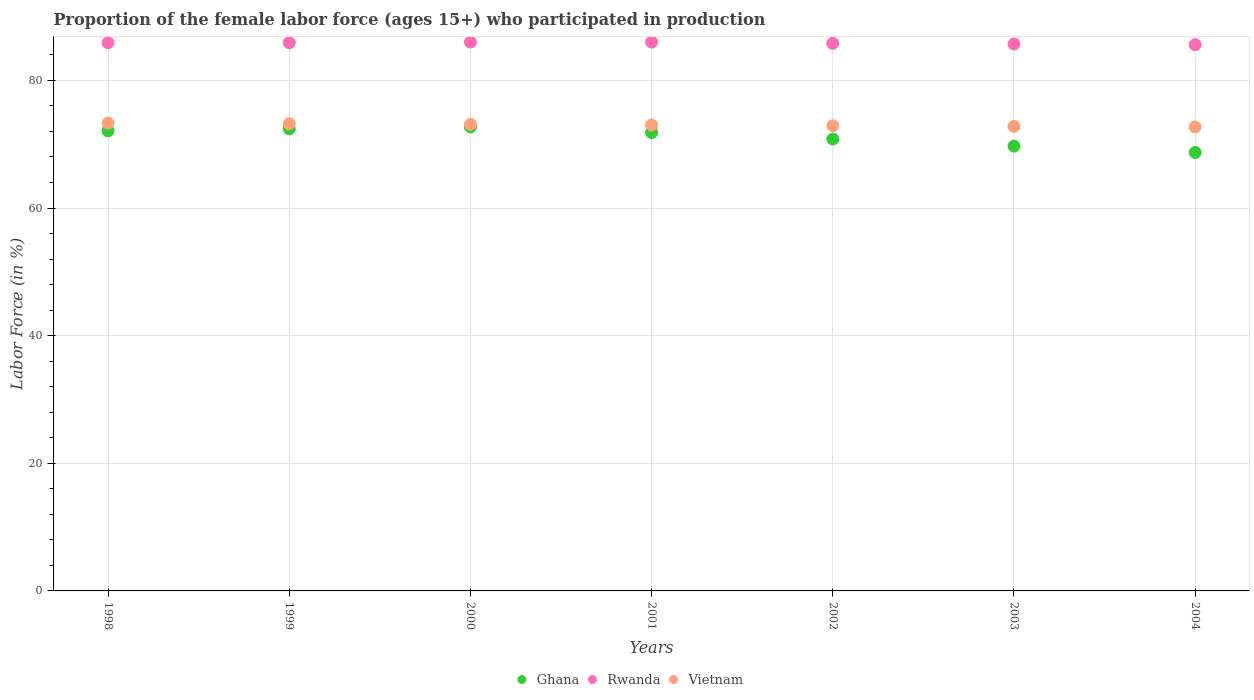What is the proportion of the female labor force who participated in production in Rwanda in 2002?
Your answer should be very brief. 85.8. Across all years, what is the minimum proportion of the female labor force who participated in production in Rwanda?
Give a very brief answer. 85.6. In which year was the proportion of the female labor force who participated in production in Vietnam maximum?
Offer a terse response. 1998. In which year was the proportion of the female labor force who participated in production in Ghana minimum?
Your answer should be compact. 2004. What is the total proportion of the female labor force who participated in production in Ghana in the graph?
Offer a terse response. 498.2. What is the difference between the proportion of the female labor force who participated in production in Vietnam in 2002 and that in 2004?
Your response must be concise. 0.2. What is the difference between the proportion of the female labor force who participated in production in Rwanda in 2004 and the proportion of the female labor force who participated in production in Ghana in 1999?
Offer a very short reply. 13.2. What is the average proportion of the female labor force who participated in production in Rwanda per year?
Make the answer very short. 85.84. In the year 1998, what is the difference between the proportion of the female labor force who participated in production in Ghana and proportion of the female labor force who participated in production in Rwanda?
Provide a succinct answer. -13.8. In how many years, is the proportion of the female labor force who participated in production in Rwanda greater than 8 %?
Give a very brief answer. 7. What is the ratio of the proportion of the female labor force who participated in production in Rwanda in 2001 to that in 2003?
Give a very brief answer. 1. Is the proportion of the female labor force who participated in production in Rwanda in 2001 less than that in 2004?
Ensure brevity in your answer.  No. Is the difference between the proportion of the female labor force who participated in production in Ghana in 1998 and 2002 greater than the difference between the proportion of the female labor force who participated in production in Rwanda in 1998 and 2002?
Make the answer very short. Yes. What is the difference between the highest and the second highest proportion of the female labor force who participated in production in Ghana?
Provide a short and direct response. 0.3. What is the difference between the highest and the lowest proportion of the female labor force who participated in production in Rwanda?
Your answer should be compact. 0.4. Is it the case that in every year, the sum of the proportion of the female labor force who participated in production in Rwanda and proportion of the female labor force who participated in production in Vietnam  is greater than the proportion of the female labor force who participated in production in Ghana?
Offer a very short reply. Yes. Is the proportion of the female labor force who participated in production in Vietnam strictly greater than the proportion of the female labor force who participated in production in Ghana over the years?
Offer a terse response. Yes. Is the proportion of the female labor force who participated in production in Rwanda strictly less than the proportion of the female labor force who participated in production in Vietnam over the years?
Offer a very short reply. No. How many years are there in the graph?
Offer a very short reply. 7. Are the values on the major ticks of Y-axis written in scientific E-notation?
Offer a terse response. No. Does the graph contain any zero values?
Offer a very short reply. No. Where does the legend appear in the graph?
Ensure brevity in your answer.  Bottom center. How are the legend labels stacked?
Provide a succinct answer. Horizontal. What is the title of the graph?
Provide a short and direct response. Proportion of the female labor force (ages 15+) who participated in production. Does "Norway" appear as one of the legend labels in the graph?
Provide a short and direct response. No. What is the label or title of the X-axis?
Provide a short and direct response. Years. What is the label or title of the Y-axis?
Your answer should be compact. Labor Force (in %). What is the Labor Force (in %) of Ghana in 1998?
Your answer should be very brief. 72.1. What is the Labor Force (in %) in Rwanda in 1998?
Your response must be concise. 85.9. What is the Labor Force (in %) in Vietnam in 1998?
Your answer should be compact. 73.3. What is the Labor Force (in %) in Ghana in 1999?
Offer a terse response. 72.4. What is the Labor Force (in %) of Rwanda in 1999?
Provide a succinct answer. 85.9. What is the Labor Force (in %) of Vietnam in 1999?
Provide a short and direct response. 73.2. What is the Labor Force (in %) in Ghana in 2000?
Make the answer very short. 72.7. What is the Labor Force (in %) in Rwanda in 2000?
Ensure brevity in your answer.  86. What is the Labor Force (in %) in Vietnam in 2000?
Offer a terse response. 73.1. What is the Labor Force (in %) of Ghana in 2001?
Make the answer very short. 71.8. What is the Labor Force (in %) in Vietnam in 2001?
Make the answer very short. 73. What is the Labor Force (in %) in Ghana in 2002?
Your response must be concise. 70.8. What is the Labor Force (in %) in Rwanda in 2002?
Make the answer very short. 85.8. What is the Labor Force (in %) of Vietnam in 2002?
Keep it short and to the point. 72.9. What is the Labor Force (in %) of Ghana in 2003?
Give a very brief answer. 69.7. What is the Labor Force (in %) of Rwanda in 2003?
Make the answer very short. 85.7. What is the Labor Force (in %) of Vietnam in 2003?
Ensure brevity in your answer.  72.8. What is the Labor Force (in %) in Ghana in 2004?
Your response must be concise. 68.7. What is the Labor Force (in %) in Rwanda in 2004?
Make the answer very short. 85.6. What is the Labor Force (in %) in Vietnam in 2004?
Offer a terse response. 72.7. Across all years, what is the maximum Labor Force (in %) in Ghana?
Your response must be concise. 72.7. Across all years, what is the maximum Labor Force (in %) of Vietnam?
Keep it short and to the point. 73.3. Across all years, what is the minimum Labor Force (in %) in Ghana?
Give a very brief answer. 68.7. Across all years, what is the minimum Labor Force (in %) in Rwanda?
Keep it short and to the point. 85.6. Across all years, what is the minimum Labor Force (in %) of Vietnam?
Your answer should be very brief. 72.7. What is the total Labor Force (in %) in Ghana in the graph?
Provide a succinct answer. 498.2. What is the total Labor Force (in %) of Rwanda in the graph?
Offer a terse response. 600.9. What is the total Labor Force (in %) in Vietnam in the graph?
Your answer should be compact. 511. What is the difference between the Labor Force (in %) of Rwanda in 1998 and that in 1999?
Provide a short and direct response. 0. What is the difference between the Labor Force (in %) in Vietnam in 1998 and that in 1999?
Offer a very short reply. 0.1. What is the difference between the Labor Force (in %) of Rwanda in 1998 and that in 2000?
Make the answer very short. -0.1. What is the difference between the Labor Force (in %) in Vietnam in 1998 and that in 2000?
Your answer should be compact. 0.2. What is the difference between the Labor Force (in %) in Ghana in 1998 and that in 2002?
Your response must be concise. 1.3. What is the difference between the Labor Force (in %) of Rwanda in 1998 and that in 2002?
Your answer should be very brief. 0.1. What is the difference between the Labor Force (in %) of Rwanda in 1998 and that in 2003?
Give a very brief answer. 0.2. What is the difference between the Labor Force (in %) in Ghana in 1998 and that in 2004?
Your answer should be compact. 3.4. What is the difference between the Labor Force (in %) in Rwanda in 1998 and that in 2004?
Your response must be concise. 0.3. What is the difference between the Labor Force (in %) of Vietnam in 1998 and that in 2004?
Offer a very short reply. 0.6. What is the difference between the Labor Force (in %) of Ghana in 1999 and that in 2000?
Your answer should be very brief. -0.3. What is the difference between the Labor Force (in %) of Rwanda in 1999 and that in 2000?
Provide a succinct answer. -0.1. What is the difference between the Labor Force (in %) in Vietnam in 1999 and that in 2000?
Give a very brief answer. 0.1. What is the difference between the Labor Force (in %) of Ghana in 1999 and that in 2001?
Your answer should be very brief. 0.6. What is the difference between the Labor Force (in %) of Rwanda in 1999 and that in 2002?
Your response must be concise. 0.1. What is the difference between the Labor Force (in %) of Rwanda in 1999 and that in 2004?
Offer a terse response. 0.3. What is the difference between the Labor Force (in %) in Vietnam in 1999 and that in 2004?
Ensure brevity in your answer.  0.5. What is the difference between the Labor Force (in %) in Ghana in 2000 and that in 2001?
Provide a short and direct response. 0.9. What is the difference between the Labor Force (in %) in Rwanda in 2000 and that in 2001?
Your answer should be very brief. 0. What is the difference between the Labor Force (in %) in Vietnam in 2000 and that in 2001?
Make the answer very short. 0.1. What is the difference between the Labor Force (in %) of Rwanda in 2000 and that in 2002?
Offer a terse response. 0.2. What is the difference between the Labor Force (in %) in Vietnam in 2000 and that in 2002?
Your answer should be very brief. 0.2. What is the difference between the Labor Force (in %) in Ghana in 2000 and that in 2003?
Make the answer very short. 3. What is the difference between the Labor Force (in %) of Ghana in 2000 and that in 2004?
Your response must be concise. 4. What is the difference between the Labor Force (in %) of Vietnam in 2000 and that in 2004?
Offer a very short reply. 0.4. What is the difference between the Labor Force (in %) of Ghana in 2001 and that in 2002?
Keep it short and to the point. 1. What is the difference between the Labor Force (in %) in Rwanda in 2001 and that in 2002?
Provide a succinct answer. 0.2. What is the difference between the Labor Force (in %) of Vietnam in 2001 and that in 2002?
Give a very brief answer. 0.1. What is the difference between the Labor Force (in %) in Rwanda in 2001 and that in 2003?
Give a very brief answer. 0.3. What is the difference between the Labor Force (in %) of Ghana in 2001 and that in 2004?
Ensure brevity in your answer.  3.1. What is the difference between the Labor Force (in %) in Vietnam in 2002 and that in 2003?
Offer a terse response. 0.1. What is the difference between the Labor Force (in %) in Ghana in 2002 and that in 2004?
Your answer should be compact. 2.1. What is the difference between the Labor Force (in %) of Vietnam in 2002 and that in 2004?
Your answer should be very brief. 0.2. What is the difference between the Labor Force (in %) in Vietnam in 2003 and that in 2004?
Your answer should be very brief. 0.1. What is the difference between the Labor Force (in %) in Ghana in 1998 and the Labor Force (in %) in Rwanda in 2000?
Your answer should be very brief. -13.9. What is the difference between the Labor Force (in %) in Rwanda in 1998 and the Labor Force (in %) in Vietnam in 2001?
Offer a very short reply. 12.9. What is the difference between the Labor Force (in %) in Ghana in 1998 and the Labor Force (in %) in Rwanda in 2002?
Ensure brevity in your answer.  -13.7. What is the difference between the Labor Force (in %) in Rwanda in 1998 and the Labor Force (in %) in Vietnam in 2002?
Keep it short and to the point. 13. What is the difference between the Labor Force (in %) of Ghana in 1998 and the Labor Force (in %) of Rwanda in 2003?
Give a very brief answer. -13.6. What is the difference between the Labor Force (in %) in Ghana in 1998 and the Labor Force (in %) in Vietnam in 2004?
Provide a short and direct response. -0.6. What is the difference between the Labor Force (in %) in Ghana in 1999 and the Labor Force (in %) in Rwanda in 2000?
Offer a very short reply. -13.6. What is the difference between the Labor Force (in %) of Ghana in 1999 and the Labor Force (in %) of Vietnam in 2000?
Your answer should be compact. -0.7. What is the difference between the Labor Force (in %) of Rwanda in 1999 and the Labor Force (in %) of Vietnam in 2000?
Offer a terse response. 12.8. What is the difference between the Labor Force (in %) in Ghana in 1999 and the Labor Force (in %) in Rwanda in 2001?
Offer a terse response. -13.6. What is the difference between the Labor Force (in %) in Ghana in 1999 and the Labor Force (in %) in Rwanda in 2002?
Offer a very short reply. -13.4. What is the difference between the Labor Force (in %) in Rwanda in 1999 and the Labor Force (in %) in Vietnam in 2002?
Make the answer very short. 13. What is the difference between the Labor Force (in %) of Ghana in 1999 and the Labor Force (in %) of Vietnam in 2003?
Your answer should be compact. -0.4. What is the difference between the Labor Force (in %) of Rwanda in 1999 and the Labor Force (in %) of Vietnam in 2003?
Give a very brief answer. 13.1. What is the difference between the Labor Force (in %) in Ghana in 1999 and the Labor Force (in %) in Rwanda in 2004?
Your response must be concise. -13.2. What is the difference between the Labor Force (in %) of Ghana in 1999 and the Labor Force (in %) of Vietnam in 2004?
Make the answer very short. -0.3. What is the difference between the Labor Force (in %) in Ghana in 2000 and the Labor Force (in %) in Vietnam in 2001?
Make the answer very short. -0.3. What is the difference between the Labor Force (in %) in Rwanda in 2000 and the Labor Force (in %) in Vietnam in 2001?
Make the answer very short. 13. What is the difference between the Labor Force (in %) in Ghana in 2000 and the Labor Force (in %) in Vietnam in 2002?
Provide a succinct answer. -0.2. What is the difference between the Labor Force (in %) of Ghana in 2000 and the Labor Force (in %) of Vietnam in 2003?
Provide a short and direct response. -0.1. What is the difference between the Labor Force (in %) in Ghana in 2000 and the Labor Force (in %) in Rwanda in 2004?
Provide a short and direct response. -12.9. What is the difference between the Labor Force (in %) in Ghana in 2001 and the Labor Force (in %) in Rwanda in 2002?
Offer a terse response. -14. What is the difference between the Labor Force (in %) in Ghana in 2001 and the Labor Force (in %) in Vietnam in 2003?
Give a very brief answer. -1. What is the difference between the Labor Force (in %) of Rwanda in 2001 and the Labor Force (in %) of Vietnam in 2003?
Provide a succinct answer. 13.2. What is the difference between the Labor Force (in %) of Ghana in 2001 and the Labor Force (in %) of Vietnam in 2004?
Your response must be concise. -0.9. What is the difference between the Labor Force (in %) of Ghana in 2002 and the Labor Force (in %) of Rwanda in 2003?
Give a very brief answer. -14.9. What is the difference between the Labor Force (in %) in Ghana in 2002 and the Labor Force (in %) in Vietnam in 2003?
Offer a terse response. -2. What is the difference between the Labor Force (in %) in Rwanda in 2002 and the Labor Force (in %) in Vietnam in 2003?
Your response must be concise. 13. What is the difference between the Labor Force (in %) in Ghana in 2002 and the Labor Force (in %) in Rwanda in 2004?
Offer a terse response. -14.8. What is the difference between the Labor Force (in %) of Rwanda in 2002 and the Labor Force (in %) of Vietnam in 2004?
Give a very brief answer. 13.1. What is the difference between the Labor Force (in %) in Ghana in 2003 and the Labor Force (in %) in Rwanda in 2004?
Offer a very short reply. -15.9. What is the average Labor Force (in %) in Ghana per year?
Your response must be concise. 71.17. What is the average Labor Force (in %) in Rwanda per year?
Keep it short and to the point. 85.84. In the year 1998, what is the difference between the Labor Force (in %) of Ghana and Labor Force (in %) of Vietnam?
Keep it short and to the point. -1.2. In the year 1999, what is the difference between the Labor Force (in %) of Ghana and Labor Force (in %) of Rwanda?
Your answer should be compact. -13.5. In the year 1999, what is the difference between the Labor Force (in %) in Ghana and Labor Force (in %) in Vietnam?
Keep it short and to the point. -0.8. In the year 1999, what is the difference between the Labor Force (in %) in Rwanda and Labor Force (in %) in Vietnam?
Offer a very short reply. 12.7. In the year 2000, what is the difference between the Labor Force (in %) in Ghana and Labor Force (in %) in Vietnam?
Provide a succinct answer. -0.4. In the year 2000, what is the difference between the Labor Force (in %) in Rwanda and Labor Force (in %) in Vietnam?
Provide a short and direct response. 12.9. In the year 2001, what is the difference between the Labor Force (in %) in Rwanda and Labor Force (in %) in Vietnam?
Ensure brevity in your answer.  13. In the year 2002, what is the difference between the Labor Force (in %) in Ghana and Labor Force (in %) in Rwanda?
Ensure brevity in your answer.  -15. In the year 2002, what is the difference between the Labor Force (in %) of Ghana and Labor Force (in %) of Vietnam?
Your answer should be compact. -2.1. In the year 2002, what is the difference between the Labor Force (in %) in Rwanda and Labor Force (in %) in Vietnam?
Your answer should be compact. 12.9. In the year 2003, what is the difference between the Labor Force (in %) of Ghana and Labor Force (in %) of Vietnam?
Provide a short and direct response. -3.1. In the year 2004, what is the difference between the Labor Force (in %) of Ghana and Labor Force (in %) of Rwanda?
Your response must be concise. -16.9. What is the ratio of the Labor Force (in %) of Ghana in 1998 to that in 1999?
Make the answer very short. 1. What is the ratio of the Labor Force (in %) of Vietnam in 1998 to that in 1999?
Provide a succinct answer. 1. What is the ratio of the Labor Force (in %) of Ghana in 1998 to that in 2000?
Give a very brief answer. 0.99. What is the ratio of the Labor Force (in %) of Rwanda in 1998 to that in 2000?
Offer a terse response. 1. What is the ratio of the Labor Force (in %) in Vietnam in 1998 to that in 2000?
Provide a succinct answer. 1. What is the ratio of the Labor Force (in %) in Ghana in 1998 to that in 2002?
Keep it short and to the point. 1.02. What is the ratio of the Labor Force (in %) of Vietnam in 1998 to that in 2002?
Provide a succinct answer. 1.01. What is the ratio of the Labor Force (in %) in Ghana in 1998 to that in 2003?
Offer a terse response. 1.03. What is the ratio of the Labor Force (in %) of Ghana in 1998 to that in 2004?
Your answer should be compact. 1.05. What is the ratio of the Labor Force (in %) of Vietnam in 1998 to that in 2004?
Your answer should be compact. 1.01. What is the ratio of the Labor Force (in %) in Rwanda in 1999 to that in 2000?
Your response must be concise. 1. What is the ratio of the Labor Force (in %) in Ghana in 1999 to that in 2001?
Your response must be concise. 1.01. What is the ratio of the Labor Force (in %) in Rwanda in 1999 to that in 2001?
Keep it short and to the point. 1. What is the ratio of the Labor Force (in %) of Ghana in 1999 to that in 2002?
Make the answer very short. 1.02. What is the ratio of the Labor Force (in %) of Vietnam in 1999 to that in 2002?
Ensure brevity in your answer.  1. What is the ratio of the Labor Force (in %) in Ghana in 1999 to that in 2003?
Your response must be concise. 1.04. What is the ratio of the Labor Force (in %) of Rwanda in 1999 to that in 2003?
Give a very brief answer. 1. What is the ratio of the Labor Force (in %) in Vietnam in 1999 to that in 2003?
Give a very brief answer. 1.01. What is the ratio of the Labor Force (in %) of Ghana in 1999 to that in 2004?
Your response must be concise. 1.05. What is the ratio of the Labor Force (in %) in Ghana in 2000 to that in 2001?
Offer a terse response. 1.01. What is the ratio of the Labor Force (in %) in Rwanda in 2000 to that in 2001?
Make the answer very short. 1. What is the ratio of the Labor Force (in %) in Ghana in 2000 to that in 2002?
Your answer should be very brief. 1.03. What is the ratio of the Labor Force (in %) of Rwanda in 2000 to that in 2002?
Your answer should be compact. 1. What is the ratio of the Labor Force (in %) of Vietnam in 2000 to that in 2002?
Offer a very short reply. 1. What is the ratio of the Labor Force (in %) of Ghana in 2000 to that in 2003?
Offer a very short reply. 1.04. What is the ratio of the Labor Force (in %) in Rwanda in 2000 to that in 2003?
Keep it short and to the point. 1. What is the ratio of the Labor Force (in %) of Ghana in 2000 to that in 2004?
Your answer should be very brief. 1.06. What is the ratio of the Labor Force (in %) in Rwanda in 2000 to that in 2004?
Offer a very short reply. 1. What is the ratio of the Labor Force (in %) of Vietnam in 2000 to that in 2004?
Give a very brief answer. 1.01. What is the ratio of the Labor Force (in %) of Ghana in 2001 to that in 2002?
Offer a terse response. 1.01. What is the ratio of the Labor Force (in %) in Rwanda in 2001 to that in 2002?
Give a very brief answer. 1. What is the ratio of the Labor Force (in %) of Ghana in 2001 to that in 2003?
Provide a succinct answer. 1.03. What is the ratio of the Labor Force (in %) in Rwanda in 2001 to that in 2003?
Make the answer very short. 1. What is the ratio of the Labor Force (in %) in Vietnam in 2001 to that in 2003?
Your response must be concise. 1. What is the ratio of the Labor Force (in %) in Ghana in 2001 to that in 2004?
Provide a succinct answer. 1.05. What is the ratio of the Labor Force (in %) in Rwanda in 2001 to that in 2004?
Ensure brevity in your answer.  1. What is the ratio of the Labor Force (in %) of Ghana in 2002 to that in 2003?
Keep it short and to the point. 1.02. What is the ratio of the Labor Force (in %) of Rwanda in 2002 to that in 2003?
Your response must be concise. 1. What is the ratio of the Labor Force (in %) in Vietnam in 2002 to that in 2003?
Make the answer very short. 1. What is the ratio of the Labor Force (in %) of Ghana in 2002 to that in 2004?
Make the answer very short. 1.03. What is the ratio of the Labor Force (in %) of Rwanda in 2002 to that in 2004?
Provide a short and direct response. 1. What is the ratio of the Labor Force (in %) of Vietnam in 2002 to that in 2004?
Ensure brevity in your answer.  1. What is the ratio of the Labor Force (in %) in Ghana in 2003 to that in 2004?
Keep it short and to the point. 1.01. What is the ratio of the Labor Force (in %) of Rwanda in 2003 to that in 2004?
Keep it short and to the point. 1. What is the difference between the highest and the second highest Labor Force (in %) of Vietnam?
Make the answer very short. 0.1. What is the difference between the highest and the lowest Labor Force (in %) in Rwanda?
Offer a very short reply. 0.4. What is the difference between the highest and the lowest Labor Force (in %) of Vietnam?
Make the answer very short. 0.6. 